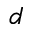Convert formula to latex. <formula><loc_0><loc_0><loc_500><loc_500>d</formula> 